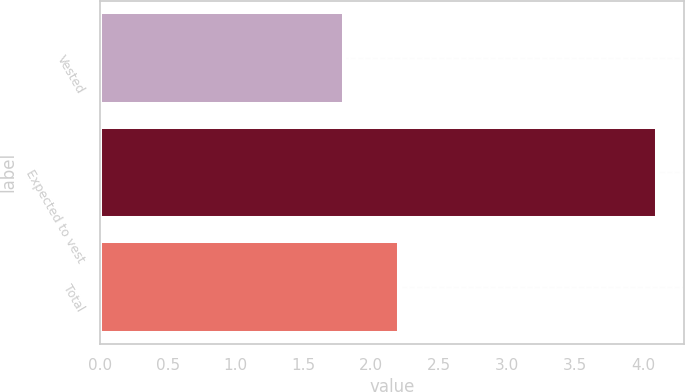Convert chart. <chart><loc_0><loc_0><loc_500><loc_500><bar_chart><fcel>Vested<fcel>Expected to vest<fcel>Total<nl><fcel>1.8<fcel>4.1<fcel>2.2<nl></chart> 